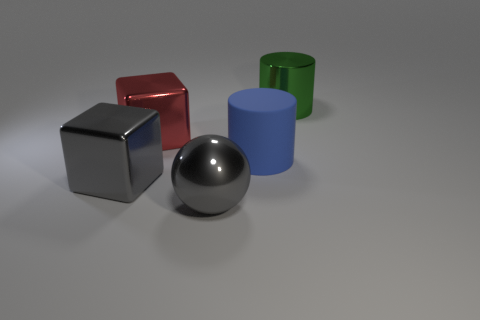There is a green shiny cylinder; are there any red shiny things on the left side of it?
Provide a short and direct response. Yes. The large thing that is in front of the large blue thing and behind the big gray sphere is what color?
Provide a short and direct response. Gray. How big is the thing that is to the right of the cylinder that is left of the big green metal thing?
Provide a short and direct response. Large. What number of cubes are either green shiny objects or large shiny objects?
Your response must be concise. 2. There is a matte cylinder that is the same size as the shiny sphere; what is its color?
Your response must be concise. Blue. There is a gray metallic thing that is right of the large block in front of the big matte thing; what is its shape?
Offer a very short reply. Sphere. Do the cylinder that is behind the red thing and the big blue cylinder have the same size?
Provide a succinct answer. Yes. How many other objects are the same material as the blue cylinder?
Ensure brevity in your answer.  0. What number of cyan things are large metallic things or large things?
Provide a succinct answer. 0. What is the size of the shiny object that is the same color as the large sphere?
Offer a very short reply. Large. 